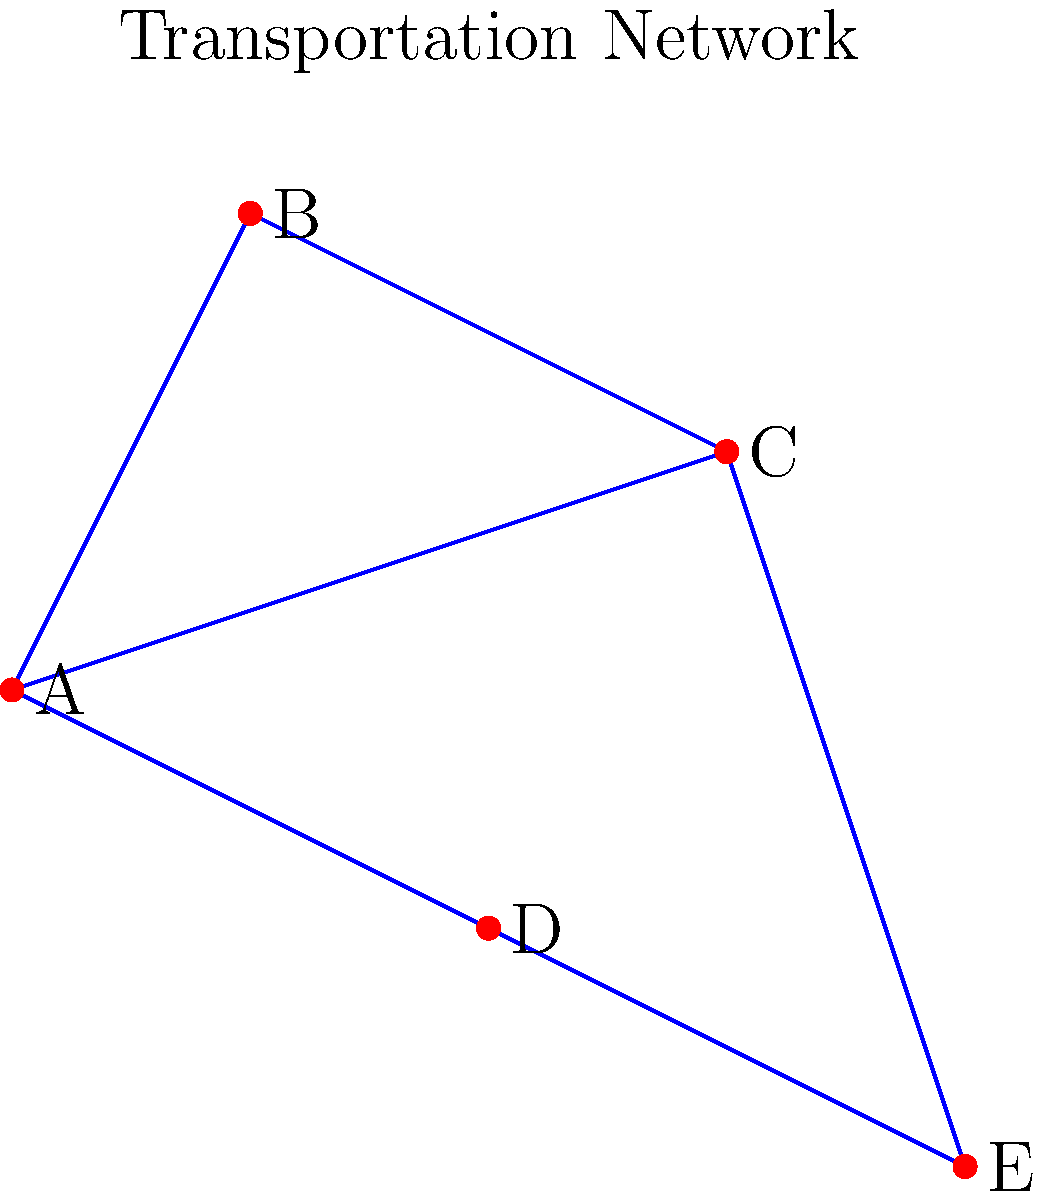In the transportation network shown above, which city acts as the most crucial hub for connectivity, and how might removing this hub impact urban development in the region? To determine the most crucial hub and its impact on urban development, we need to analyze the connectivity of each city:

1. City A: Connected to 3 other cities (B, C, D)
2. City B: Connected to 2 other cities (A, C)
3. City C: Connected to 3 other cities (A, B, E)
4. City D: Connected to 2 other cities (A, E)
5. City E: Connected to 2 other cities (C, D)

City A and City C both have the highest number of connections (3 each). However, City A is more centrally located and connects to cities in all directions, making it the most crucial hub.

If we remove City A:
1. Cities B and D would become isolated from the rest of the network.
2. The network would be split into two disconnected components: (B) and (C-D-E).
3. Travel between most city pairs would require more stops or become impossible.

Impact on urban development:
1. Decreased accessibility: Cities B and D would likely experience slower growth due to reduced connectivity.
2. Shifted economic centers: Cities C and E might see increased development as they become new connection points.
3. Increased pressure on remaining links: The connections C-E and C-D would bear more traffic, potentially requiring infrastructure upgrades.
4. Potential for new links: There might be pressure to develop new transportation links to reconnect the network, possibly between B-C or B-D.
5. Uneven development: The region might experience more uneven development, with areas near C and E growing faster than those near B and D.

In conclusion, removing City A would significantly disrupt the network's connectivity and lead to uneven urban development across the region.
Answer: City A; its removal would isolate cities, split the network, and lead to uneven regional development. 